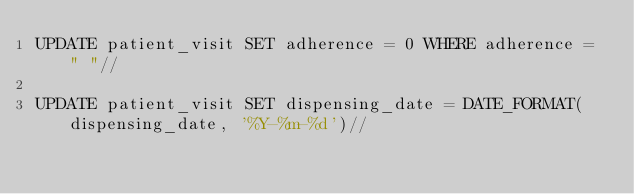<code> <loc_0><loc_0><loc_500><loc_500><_SQL_>UPDATE patient_visit SET adherence = 0 WHERE adherence = " "//

UPDATE patient_visit SET dispensing_date = DATE_FORMAT(dispensing_date, '%Y-%m-%d')//</code> 